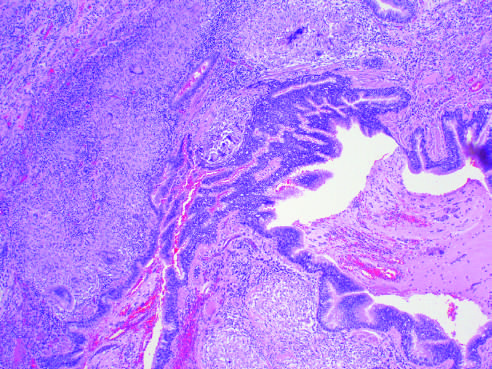re characteristic peribronchial noncaseating granulomas with many giant cells present?
Answer the question using a single word or phrase. Yes 